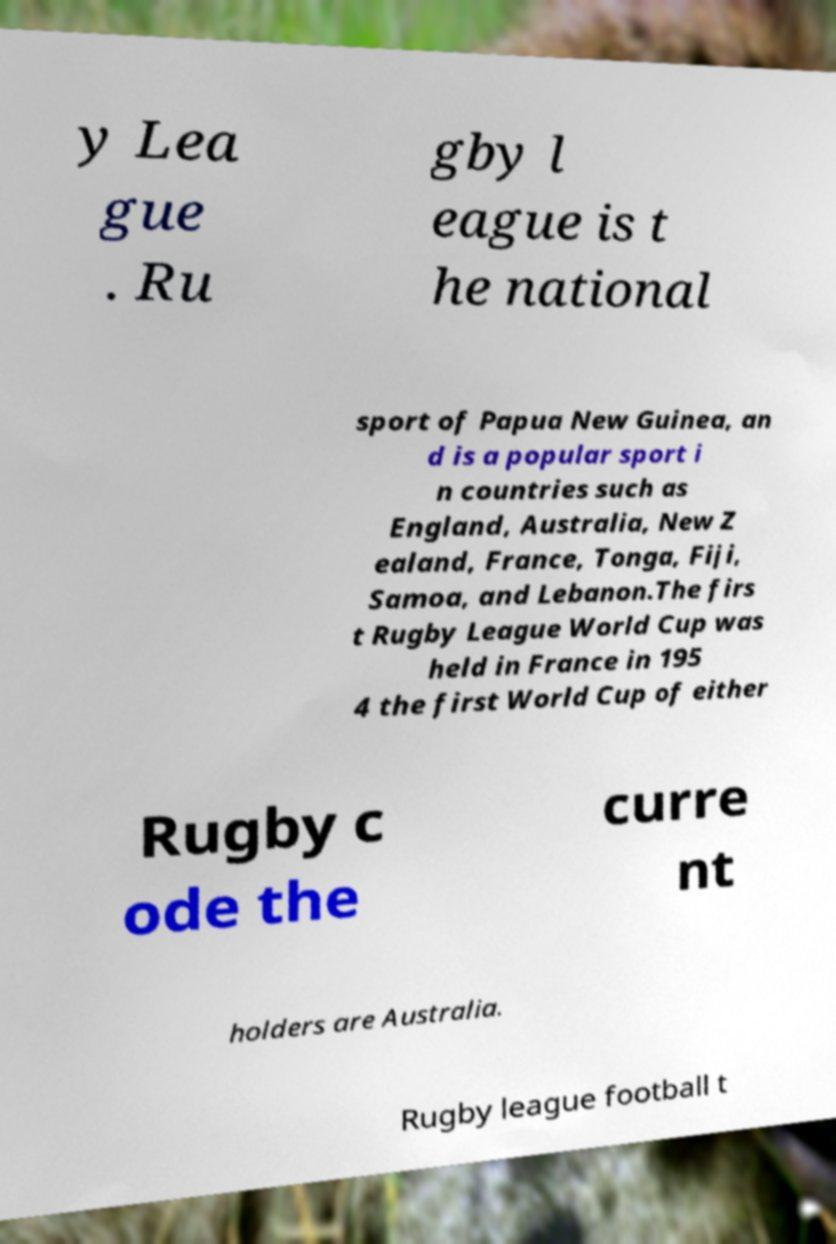Could you extract and type out the text from this image? y Lea gue . Ru gby l eague is t he national sport of Papua New Guinea, an d is a popular sport i n countries such as England, Australia, New Z ealand, France, Tonga, Fiji, Samoa, and Lebanon.The firs t Rugby League World Cup was held in France in 195 4 the first World Cup of either Rugby c ode the curre nt holders are Australia. Rugby league football t 